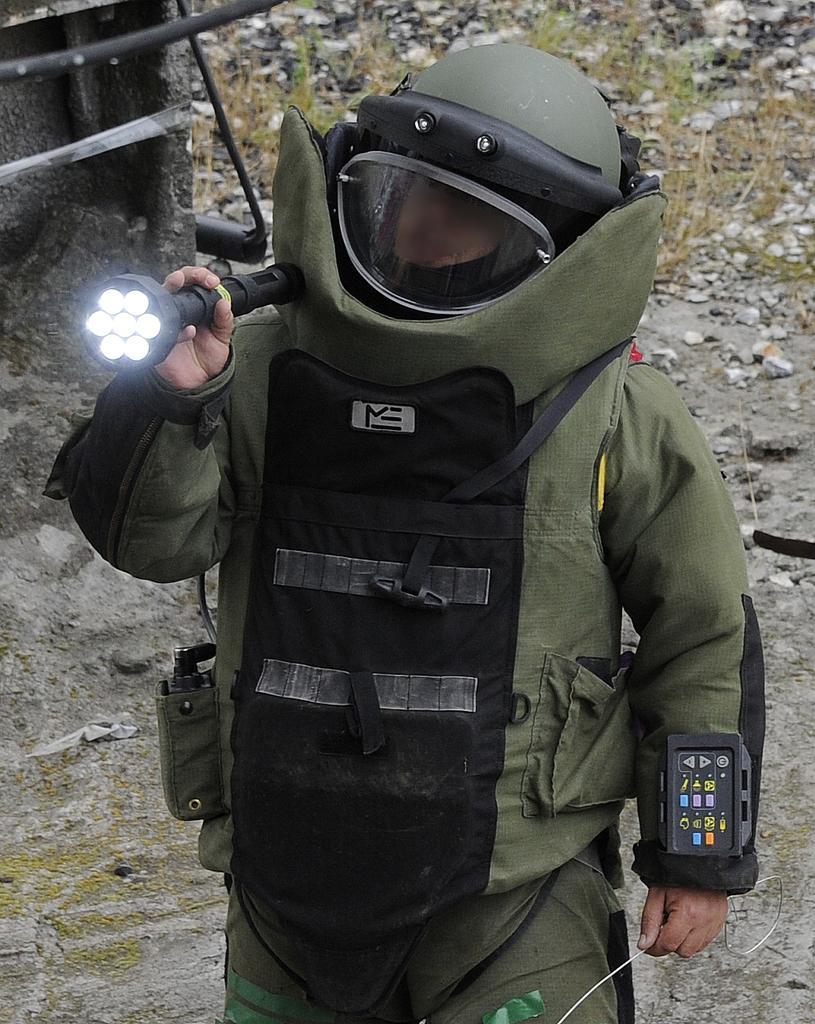In one or two sentences, can you explain what this image depicts? In the background we can see the ground, stones, grass and few objects. In this picture we can see a person wearing a helmet, holding a torch light. We can see an object in the pocket. We can see a device. 